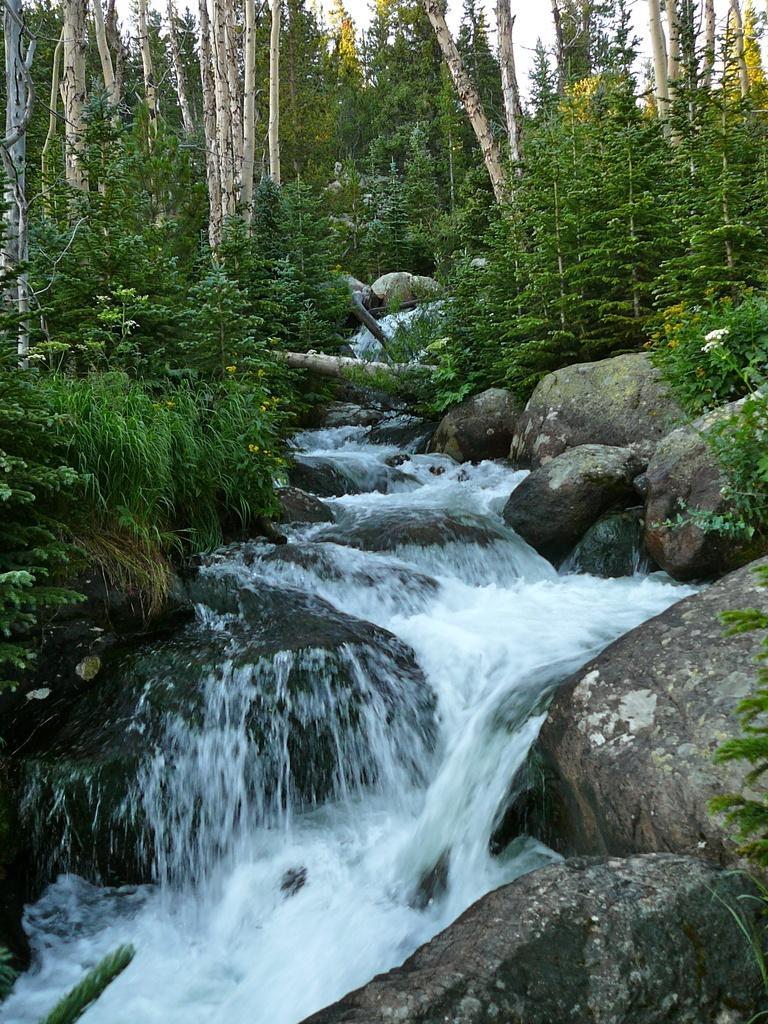Describe this image in one or two sentences. In the foreground of the picture there are rocks, plants and water flowing. In the center of the picture there are trees, plants and canal. In the background there are trees and sky. 